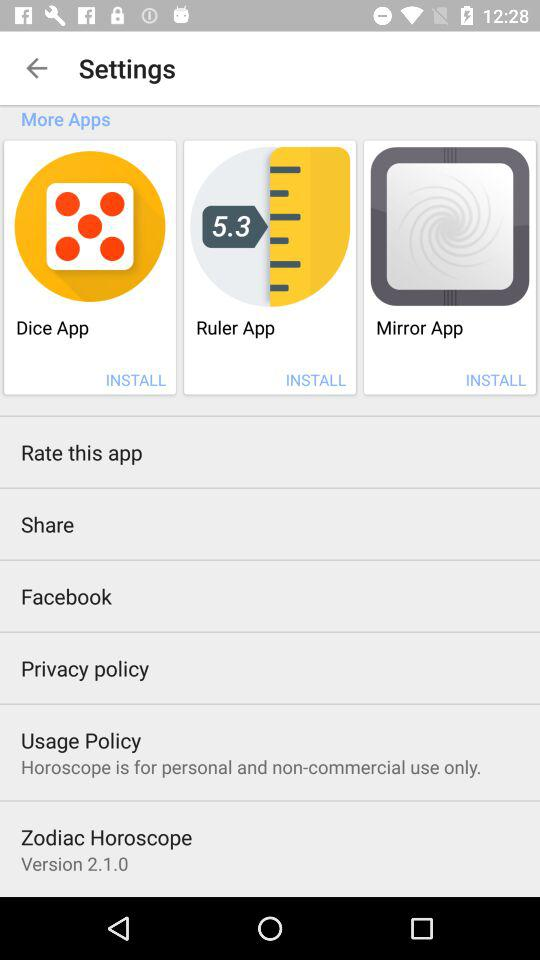What is the version of the application being used? The version is 2.1.0. 